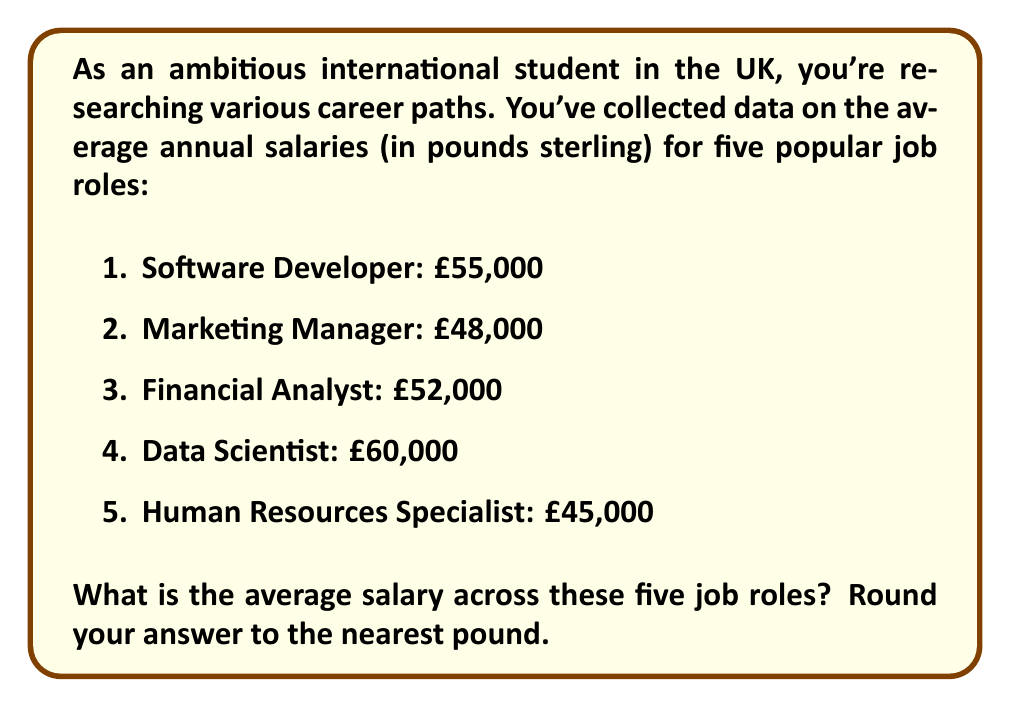Give your solution to this math problem. To find the average salary, we need to follow these steps:

1. Sum up all the salaries:
   $$55000 + 48000 + 52000 + 60000 + 45000 = 260000$$

2. Count the number of job roles:
   There are 5 job roles in total.

3. Divide the sum by the number of job roles:
   $$\text{Average} = \frac{\text{Sum of salaries}}{\text{Number of job roles}}$$
   $$\text{Average} = \frac{260000}{5} = 52000$$

Therefore, the average salary across these five job roles is £52,000.

No rounding is necessary in this case as the result is already a whole number.
Answer: £52,000 